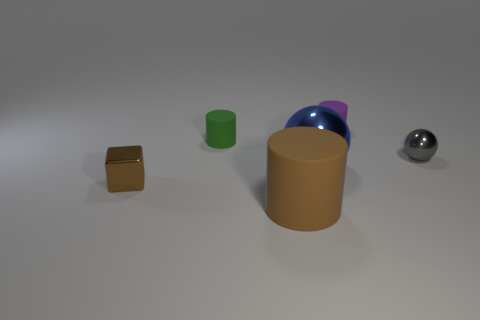Subtract all blue cylinders. Subtract all purple balls. How many cylinders are left? 3 Add 3 matte things. How many objects exist? 9 Subtract all cubes. How many objects are left? 5 Subtract 0 green cubes. How many objects are left? 6 Subtract all tiny brown spheres. Subtract all tiny balls. How many objects are left? 5 Add 5 purple objects. How many purple objects are left? 6 Add 3 green cylinders. How many green cylinders exist? 4 